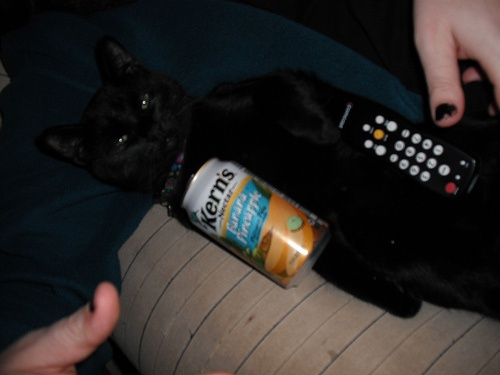Describe the objects in this image and their specific colors. I can see cat in black, darkgray, gray, and maroon tones, couch in black and gray tones, people in black and gray tones, remote in black, darkgray, gray, and maroon tones, and people in black, brown, and maroon tones in this image. 